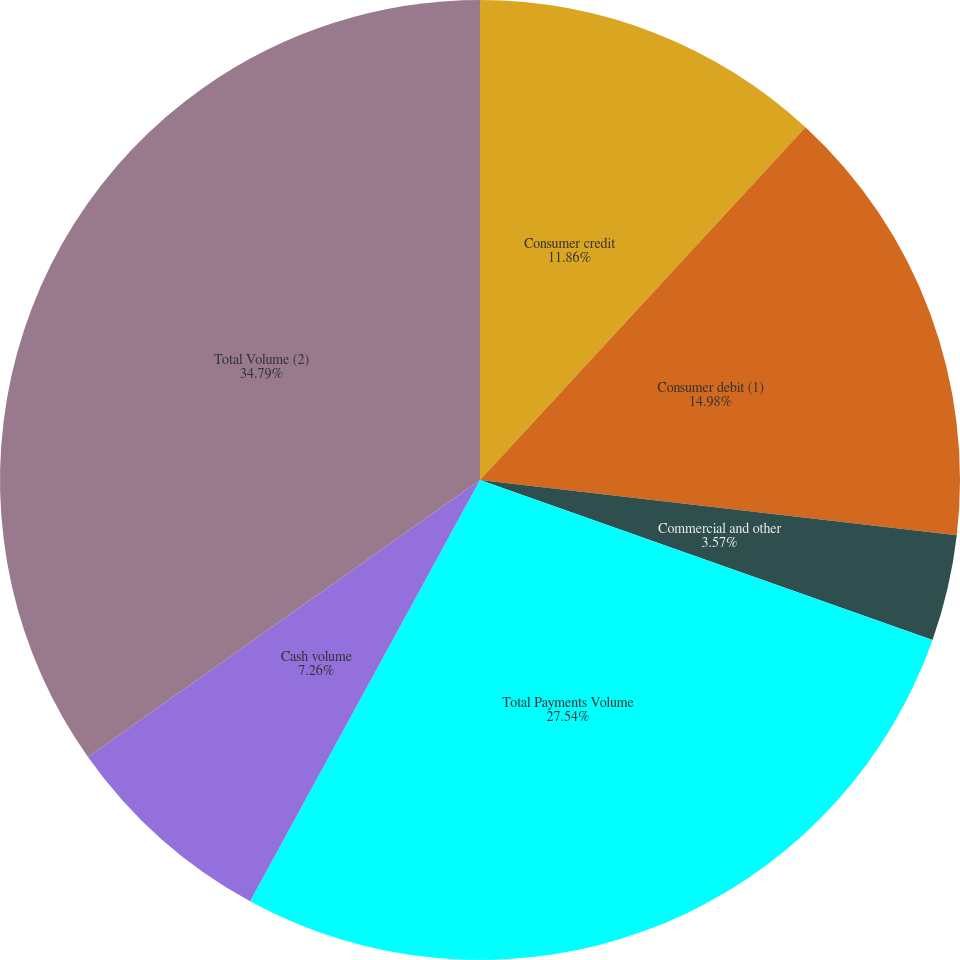<chart> <loc_0><loc_0><loc_500><loc_500><pie_chart><fcel>Consumer credit<fcel>Consumer debit (1)<fcel>Commercial and other<fcel>Total Payments Volume<fcel>Cash volume<fcel>Total Volume (2)<nl><fcel>11.86%<fcel>14.98%<fcel>3.57%<fcel>27.54%<fcel>7.26%<fcel>34.79%<nl></chart> 